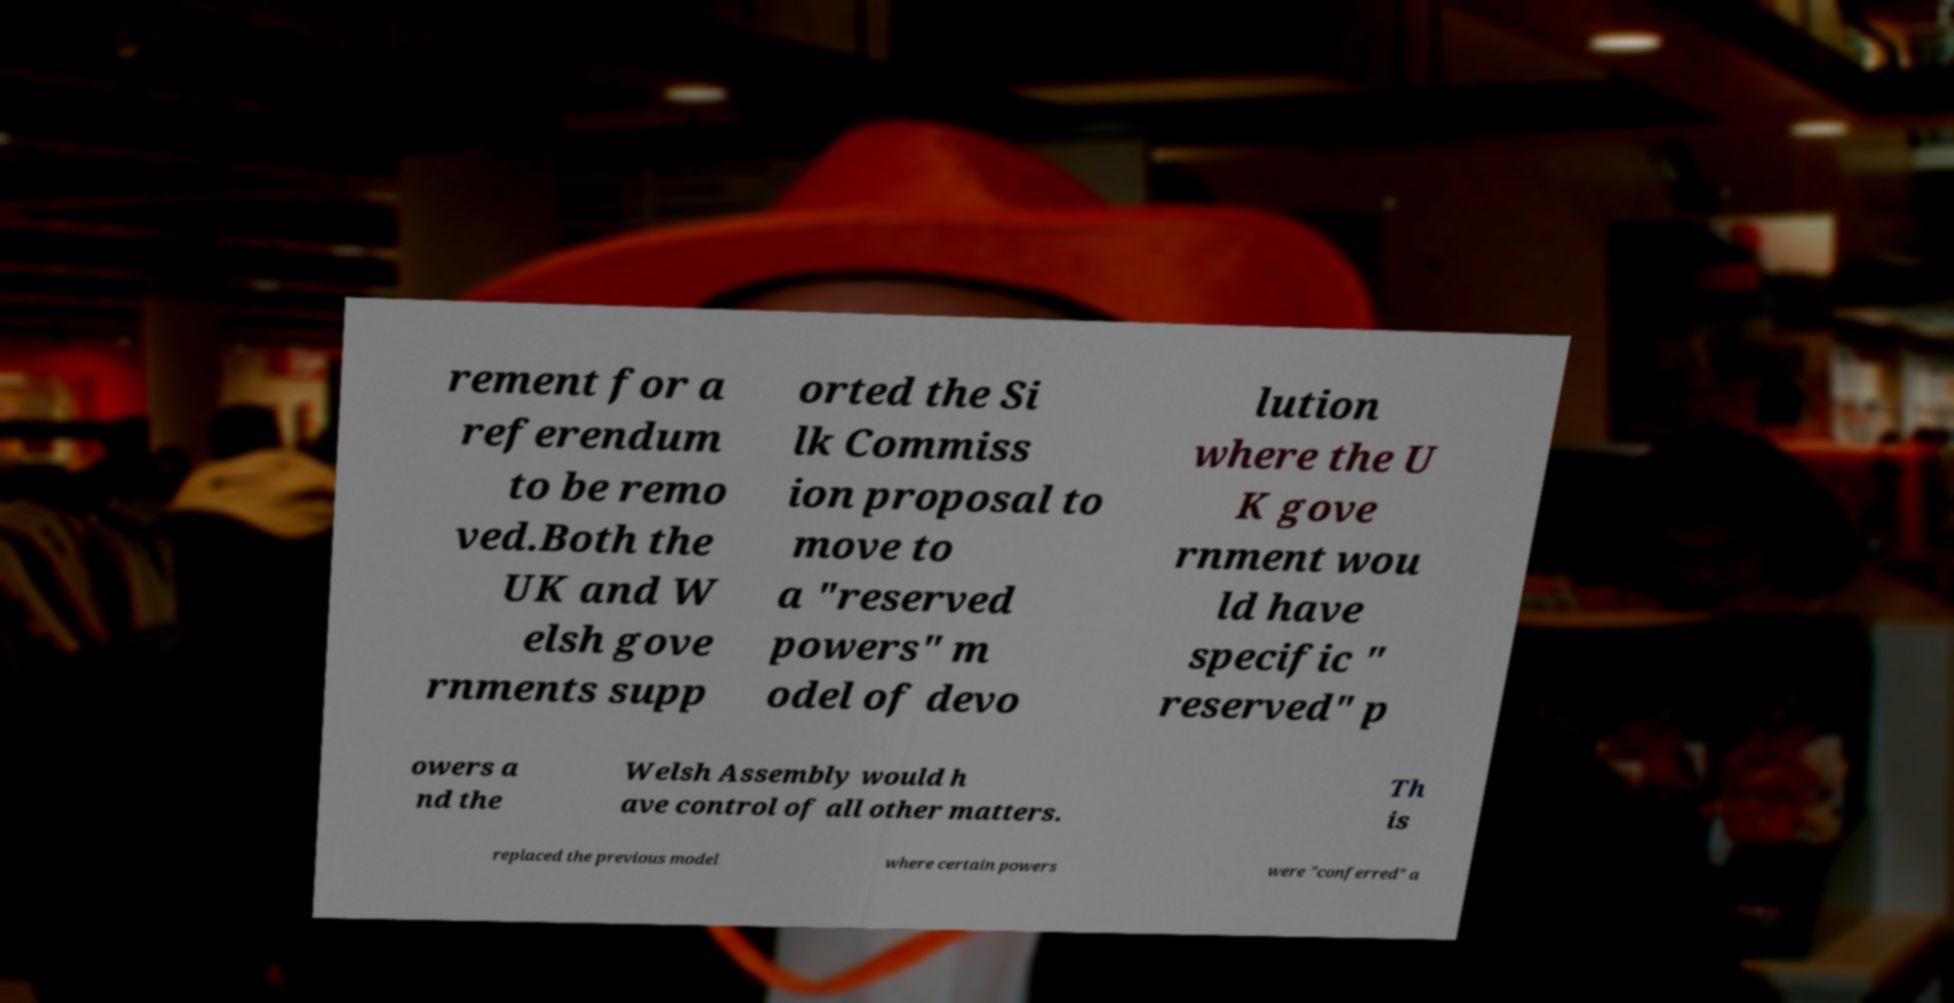Could you assist in decoding the text presented in this image and type it out clearly? rement for a referendum to be remo ved.Both the UK and W elsh gove rnments supp orted the Si lk Commiss ion proposal to move to a "reserved powers" m odel of devo lution where the U K gove rnment wou ld have specific " reserved" p owers a nd the Welsh Assembly would h ave control of all other matters. Th is replaced the previous model where certain powers were "conferred" a 